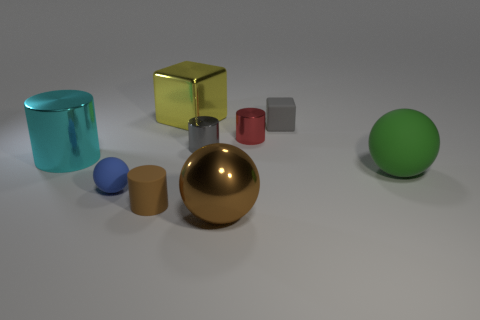What is the color of the cylinder in front of the rubber sphere that is to the right of the large metal thing that is behind the red cylinder?
Offer a very short reply. Brown. What is the shape of the large shiny thing that is in front of the large metal object on the left side of the brown matte object?
Your answer should be compact. Sphere. Are there more small brown things that are left of the small blue sphere than large brown objects?
Offer a terse response. No. There is a gray object that is in front of the red thing; is its shape the same as the big green thing?
Offer a terse response. No. Is there a gray object that has the same shape as the cyan metallic object?
Offer a terse response. Yes. What number of things are either tiny cylinders left of the big yellow metal thing or big yellow cubes?
Keep it short and to the point. 2. Is the number of small red metallic blocks greater than the number of small blue spheres?
Provide a succinct answer. No. Are there any shiny cylinders that have the same size as the blue sphere?
Provide a short and direct response. Yes. What number of things are either matte spheres that are on the right side of the blue matte sphere or metal objects on the right side of the big yellow metallic block?
Your answer should be compact. 4. The rubber sphere that is to the right of the matte ball that is on the left side of the gray metallic thing is what color?
Make the answer very short. Green. 